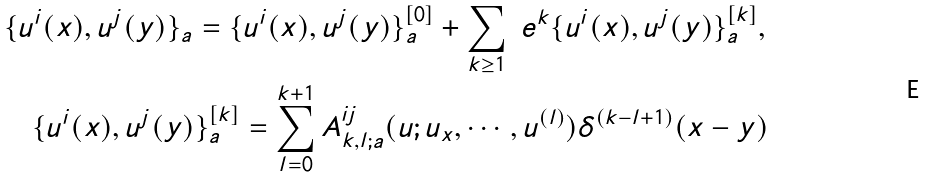Convert formula to latex. <formula><loc_0><loc_0><loc_500><loc_500>& \{ u ^ { i } ( x ) , u ^ { j } ( y ) \} _ { a } = \{ u ^ { i } ( x ) , u ^ { j } ( y ) \} _ { a } ^ { [ 0 ] } + \sum _ { k \geq 1 } \ e ^ { k } \{ u ^ { i } ( x ) , u ^ { j } ( y ) \} _ { a } ^ { [ k ] } , \\ & \quad \{ u ^ { i } ( x ) , u ^ { j } ( y ) \} _ { a } ^ { [ k ] } = \sum _ { l = 0 } ^ { k + 1 } A ^ { i j } _ { k , l ; a } ( u ; u _ { x } , \cdots , u ^ { ( l ) } ) \delta ^ { ( k - l + 1 ) } ( x - y )</formula> 